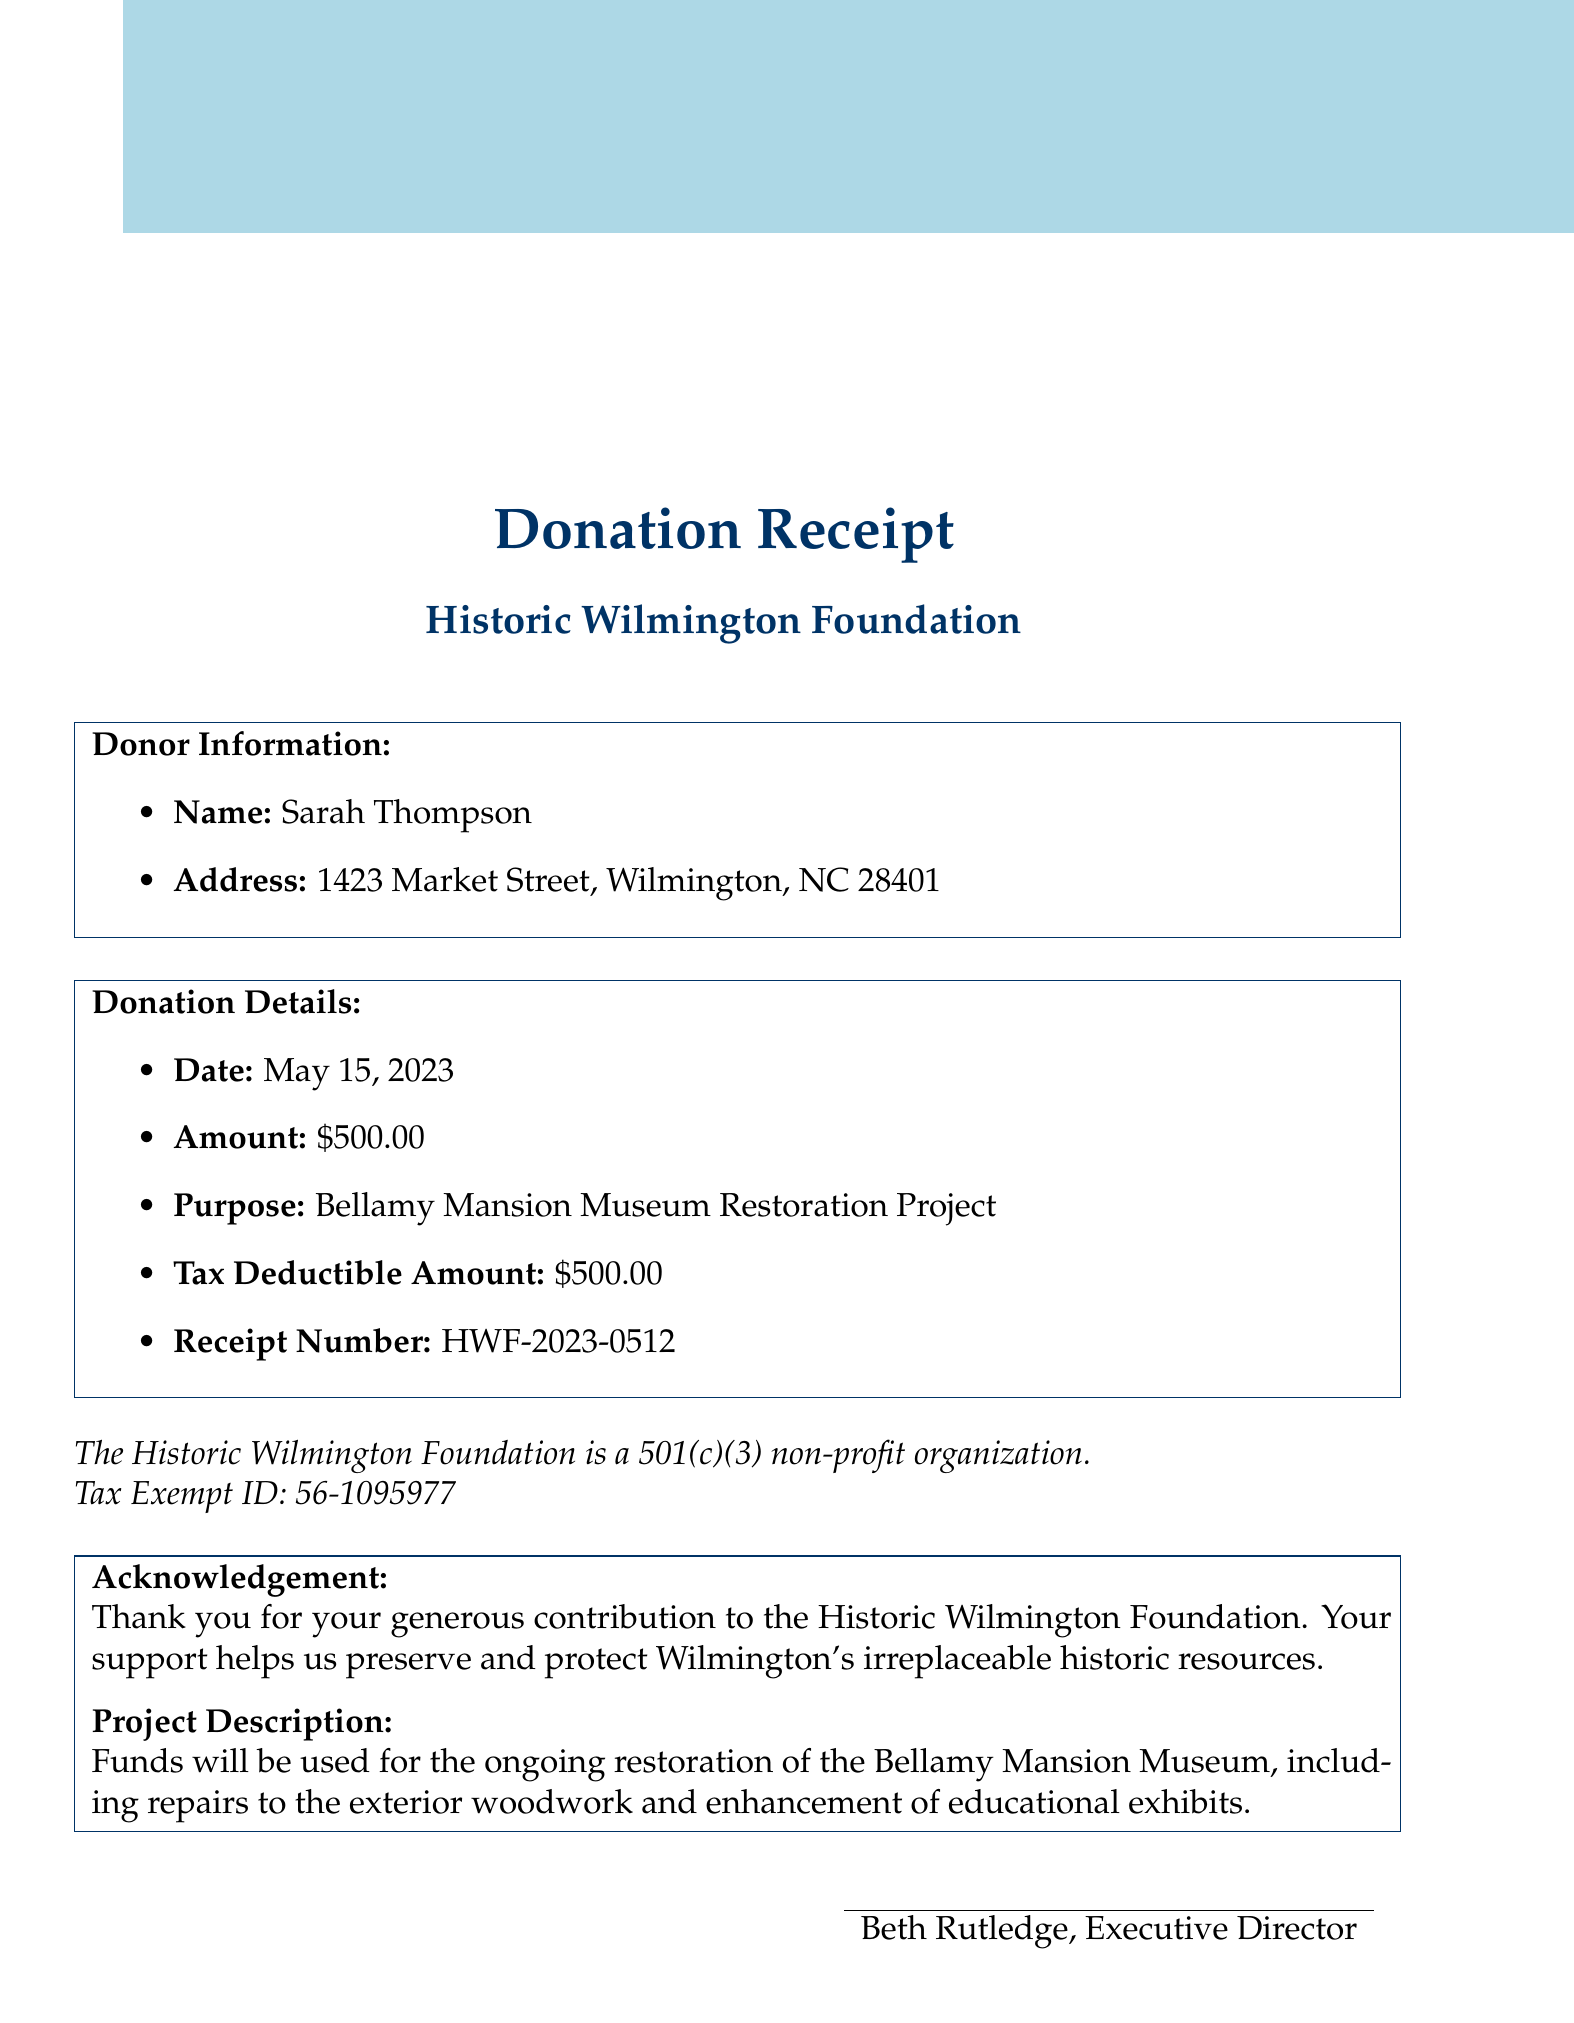What is the donation amount? The donation amount is specified directly in the document as the total contributed by the donor.
Answer: $500.00 Who is the donor? The document identifies the individual who made the donation by name.
Answer: Sarah Thompson What is the purpose of the donation? The purpose of the donation is clearly stated in the document, indicating how the funds will be utilized.
Answer: Bellamy Mansion Museum Restoration Project When was the donation made? The document provides the exact date of the donation in a clear format.
Answer: May 15, 2023 What is the tax-exempt ID? The document specifies the tax-exempt identification number, which is necessary for tax purposes.
Answer: 56-1095977 What is the acknowledgment message? The acknowledgment section thanks the donor and explains the impact of their contribution.
Answer: Thank you for your generous contribution to the Historic Wilmington Foundation. Your support helps us preserve and protect Wilmington's irreplaceable historic resources What will the funds be used for? The document outlines how the donated funds are intended to be allocated within the organization.
Answer: Ongoing restoration of the Bellamy Mansion Museum Who signed the receipt? The individual who signs the receipt is mentioned along with their title in the document, providing legitimacy to the acknowledgment.
Answer: Beth Rutledge, Executive Director What is the upcoming event mentioned? The document includes information on future events organized by the Historic Wilmington Foundation, which is relevant to community involvement.
Answer: Annual Azalea Festival Historic Home Tour, April 13-14, 2024 